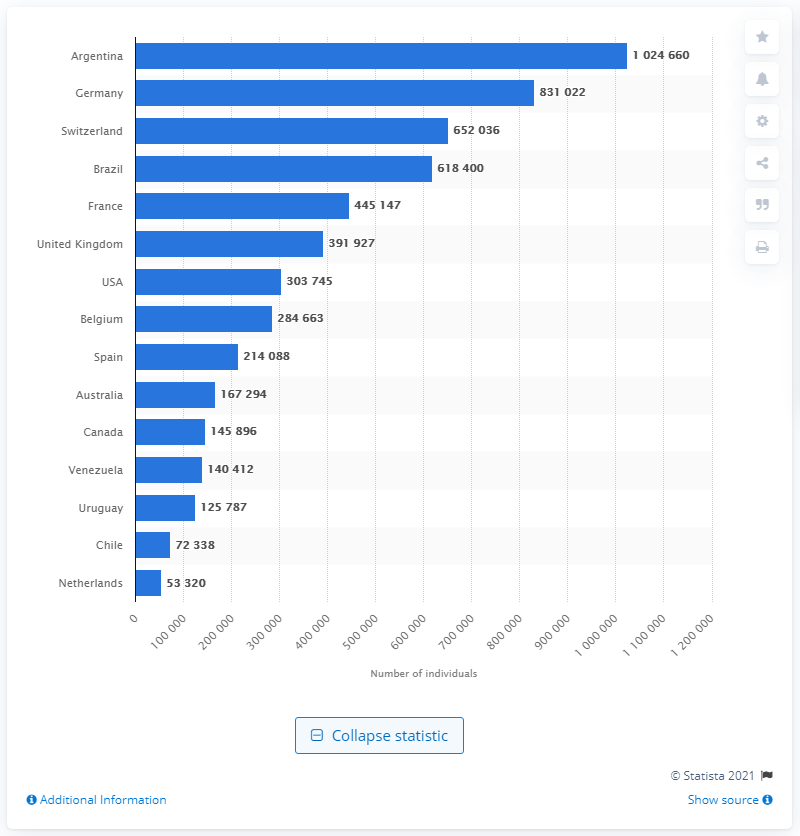Highlight a few significant elements in this photo. In Germany, there were approximately 831,022 Italian residents as of [date]. 